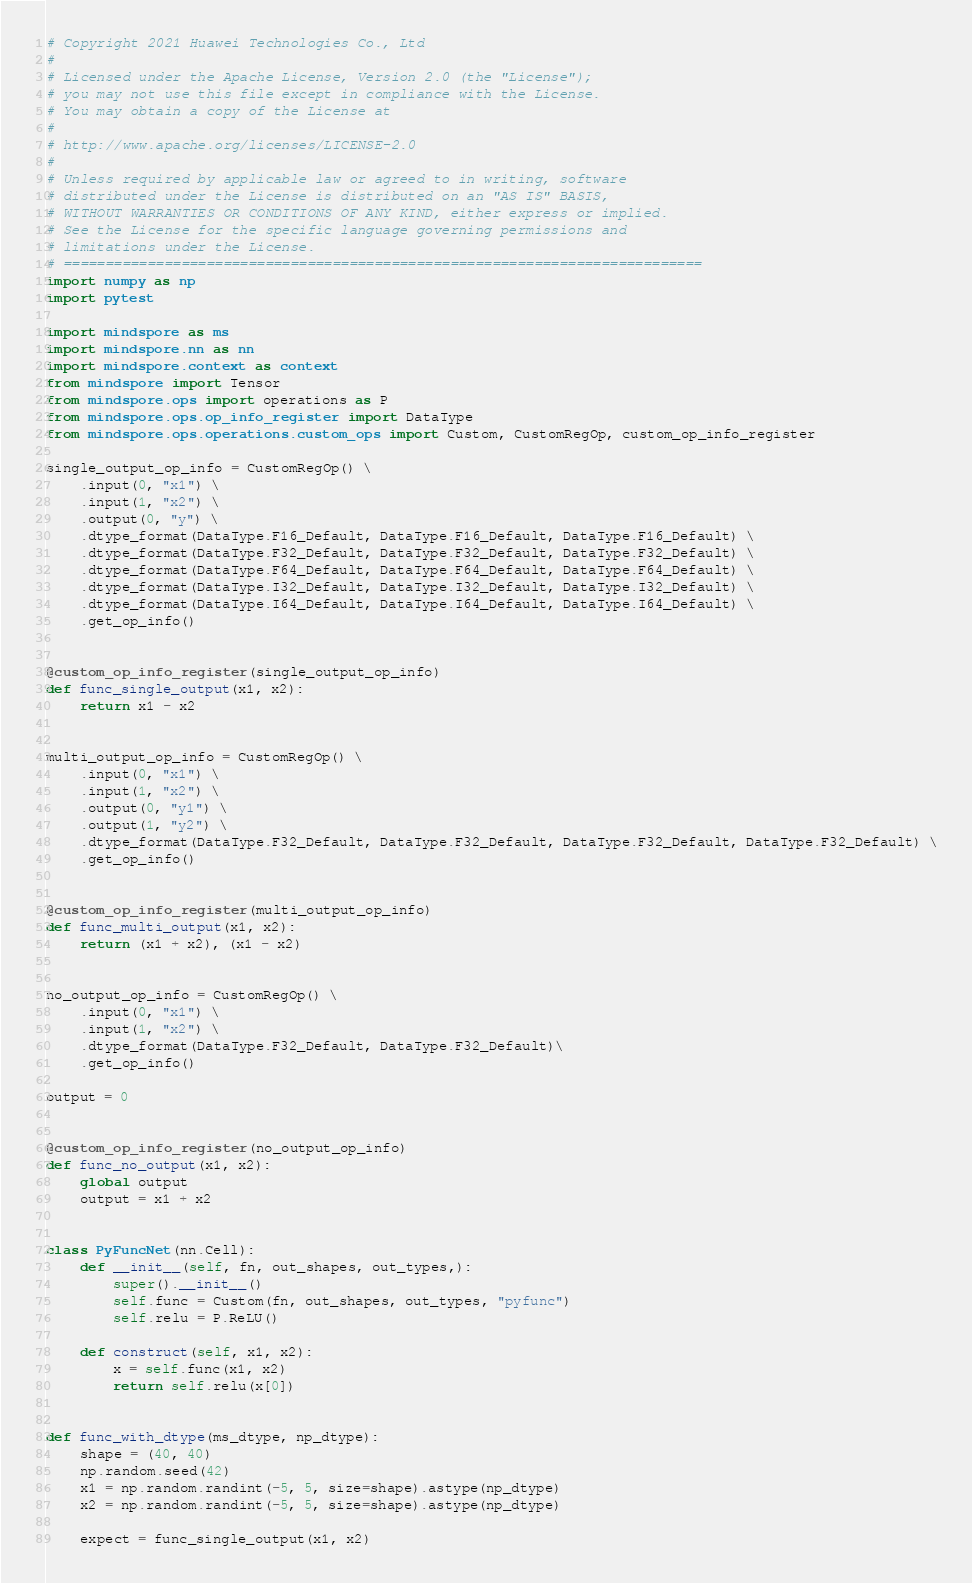Convert code to text. <code><loc_0><loc_0><loc_500><loc_500><_Python_># Copyright 2021 Huawei Technologies Co., Ltd
#
# Licensed under the Apache License, Version 2.0 (the "License");
# you may not use this file except in compliance with the License.
# You may obtain a copy of the License at
#
# http://www.apache.org/licenses/LICENSE-2.0
#
# Unless required by applicable law or agreed to in writing, software
# distributed under the License is distributed on an "AS IS" BASIS,
# WITHOUT WARRANTIES OR CONDITIONS OF ANY KIND, either express or implied.
# See the License for the specific language governing permissions and
# limitations under the License.
# ============================================================================
import numpy as np
import pytest

import mindspore as ms
import mindspore.nn as nn
import mindspore.context as context
from mindspore import Tensor
from mindspore.ops import operations as P
from mindspore.ops.op_info_register import DataType
from mindspore.ops.operations.custom_ops import Custom, CustomRegOp, custom_op_info_register

single_output_op_info = CustomRegOp() \
    .input(0, "x1") \
    .input(1, "x2") \
    .output(0, "y") \
    .dtype_format(DataType.F16_Default, DataType.F16_Default, DataType.F16_Default) \
    .dtype_format(DataType.F32_Default, DataType.F32_Default, DataType.F32_Default) \
    .dtype_format(DataType.F64_Default, DataType.F64_Default, DataType.F64_Default) \
    .dtype_format(DataType.I32_Default, DataType.I32_Default, DataType.I32_Default) \
    .dtype_format(DataType.I64_Default, DataType.I64_Default, DataType.I64_Default) \
    .get_op_info()


@custom_op_info_register(single_output_op_info)
def func_single_output(x1, x2):
    return x1 - x2


multi_output_op_info = CustomRegOp() \
    .input(0, "x1") \
    .input(1, "x2") \
    .output(0, "y1") \
    .output(1, "y2") \
    .dtype_format(DataType.F32_Default, DataType.F32_Default, DataType.F32_Default, DataType.F32_Default) \
    .get_op_info()


@custom_op_info_register(multi_output_op_info)
def func_multi_output(x1, x2):
    return (x1 + x2), (x1 - x2)


no_output_op_info = CustomRegOp() \
    .input(0, "x1") \
    .input(1, "x2") \
    .dtype_format(DataType.F32_Default, DataType.F32_Default)\
    .get_op_info()

output = 0


@custom_op_info_register(no_output_op_info)
def func_no_output(x1, x2):
    global output
    output = x1 + x2


class PyFuncNet(nn.Cell):
    def __init__(self, fn, out_shapes, out_types,):
        super().__init__()
        self.func = Custom(fn, out_shapes, out_types, "pyfunc")
        self.relu = P.ReLU()

    def construct(self, x1, x2):
        x = self.func(x1, x2)
        return self.relu(x[0])


def func_with_dtype(ms_dtype, np_dtype):
    shape = (40, 40)
    np.random.seed(42)
    x1 = np.random.randint(-5, 5, size=shape).astype(np_dtype)
    x2 = np.random.randint(-5, 5, size=shape).astype(np_dtype)

    expect = func_single_output(x1, x2)</code> 